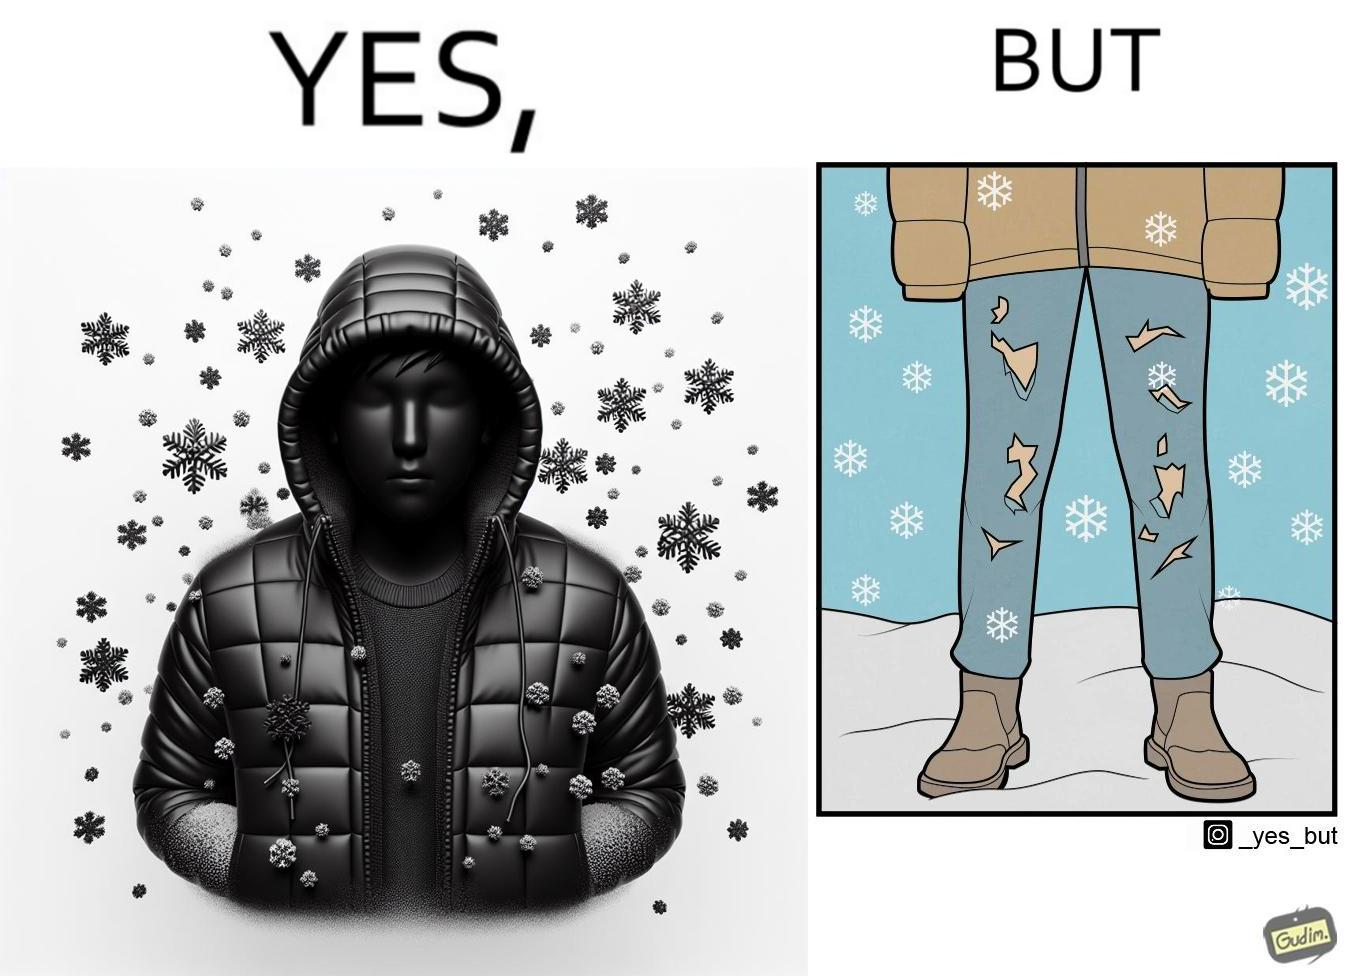What makes this image funny or satirical? This is funny because on the one hand this person is feeling very cold and has his jacket all the way up to his face, but on the other hand his trousers are torn which kind of makes the jacket redundant. 